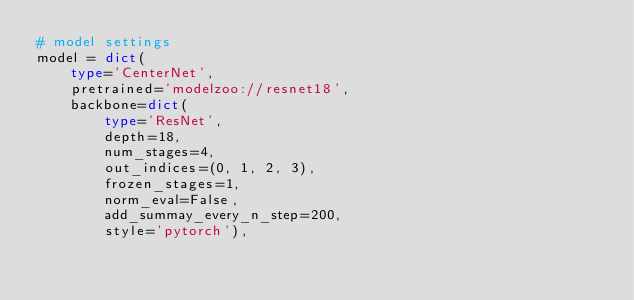Convert code to text. <code><loc_0><loc_0><loc_500><loc_500><_Python_># model settings
model = dict(
    type='CenterNet',
    pretrained='modelzoo://resnet18',
    backbone=dict(
        type='ResNet',
        depth=18,
        num_stages=4,
        out_indices=(0, 1, 2, 3),
        frozen_stages=1,
        norm_eval=False,
        add_summay_every_n_step=200,
        style='pytorch'),</code> 